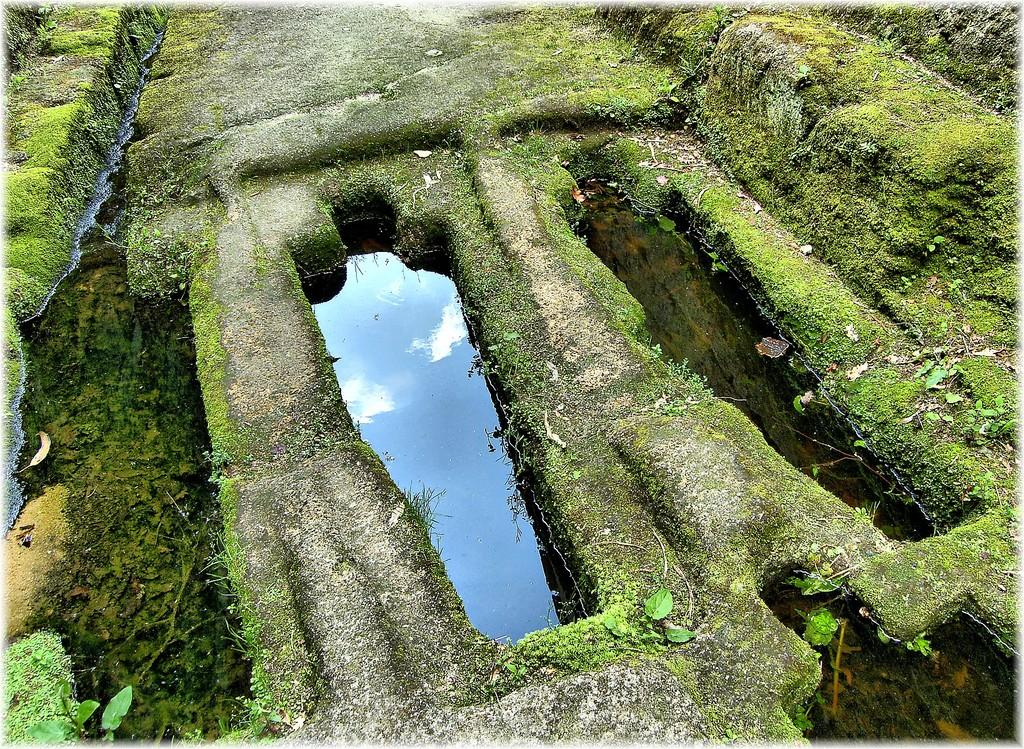What is one of the natural elements visible in the image? Water is visible in the image. What type of vegetation can be seen in the image? There is grass and plants in the image. What color are the plants, grass, and water in the image? The plants, grass, and water are all in green color. How does the light affect the growth of the bees in the image? There are no bees present in the image, and therefore their growth cannot be observed or affected by light. 